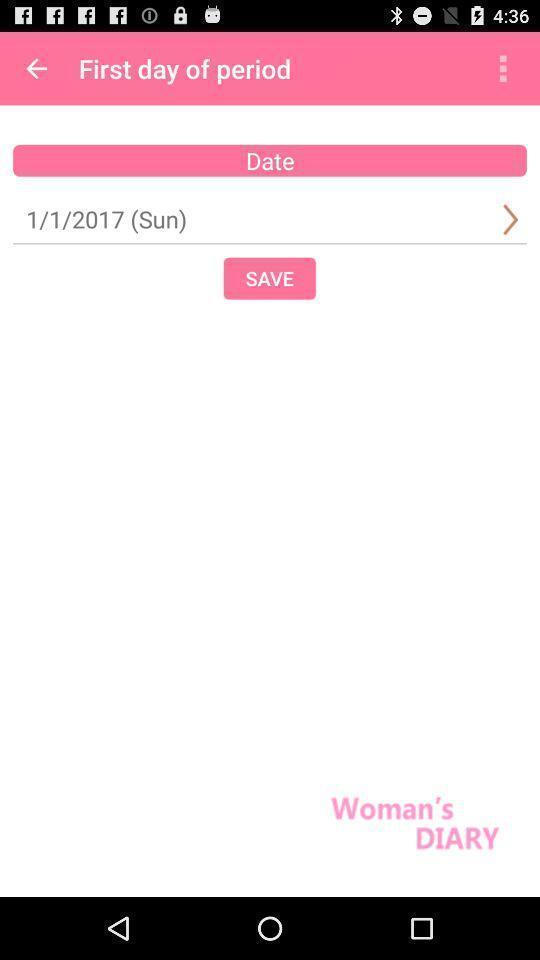What is the overall content of this screenshot? Screen displaying the women 's health page. 